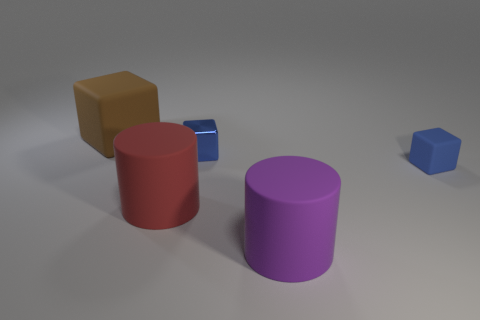Add 1 big brown objects. How many objects exist? 6 Subtract all cubes. How many objects are left? 2 Subtract all big blocks. Subtract all large red things. How many objects are left? 3 Add 3 purple matte things. How many purple matte things are left? 4 Add 4 large yellow matte cylinders. How many large yellow matte cylinders exist? 4 Subtract 0 green spheres. How many objects are left? 5 